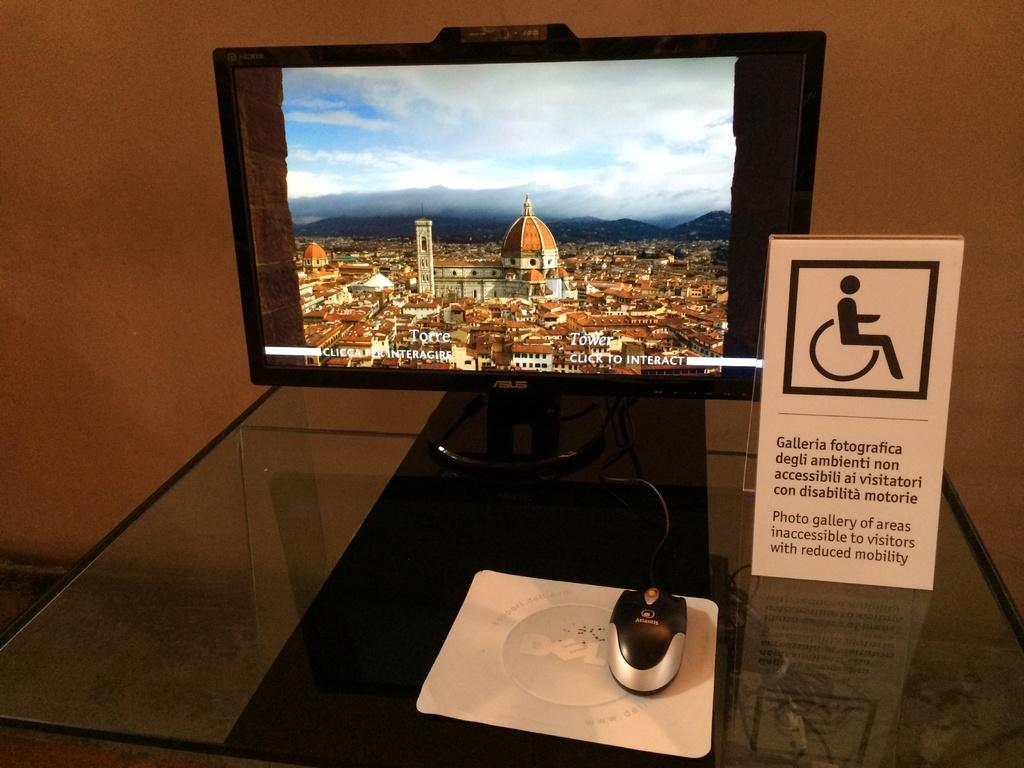<image>
Relay a brief, clear account of the picture shown. a handicap sign with galleria on  the front 